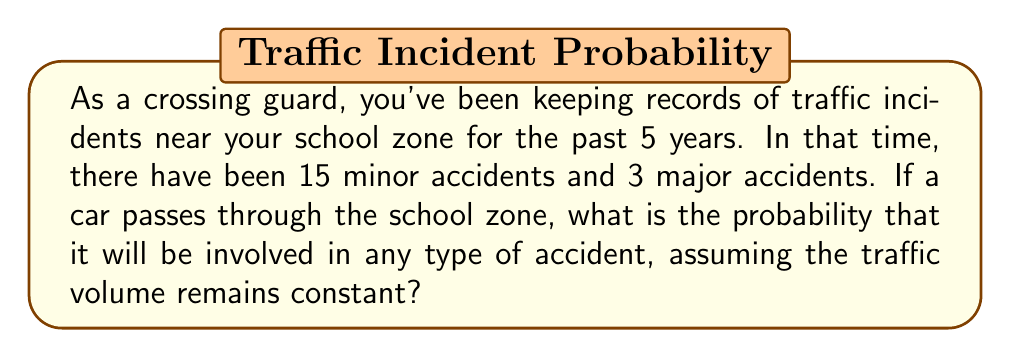Provide a solution to this math problem. Let's approach this step-by-step:

1) First, we need to calculate the total number of accidents:
   $\text{Total accidents} = \text{Minor accidents} + \text{Major accidents}$
   $\text{Total accidents} = 15 + 3 = 18$

2) Now, we need to know the total number of cars that passed through the school zone in 5 years. This information is not given, so we'll have to estimate it.

   Let's assume an average of 200 cars pass through the school zone each school day.
   There are approximately 180 school days in a year.

3) Calculate the total number of cars over 5 years:
   $\text{Total cars} = 200 \text{ cars/day} \times 180 \text{ days/year} \times 5 \text{ years} = 180,000 \text{ cars}$

4) Now we can calculate the probability. The probability of an accident is the number of accidents divided by the total number of cars:

   $$P(\text{accident}) = \frac{\text{Number of accidents}}{\text{Total number of cars}}$$

   $$P(\text{accident}) = \frac{18}{180,000} = \frac{1}{10,000} = 0.0001$$

5) This can also be expressed as a percentage:
   $0.0001 \times 100\% = 0.01\%$

Therefore, based on this historical data and our assumptions, the probability of a car being involved in an accident when passing through the school zone is 0.01% or 1 in 10,000.
Answer: $0.0001$ or $0.01\%$ or $\frac{1}{10,000}$ 